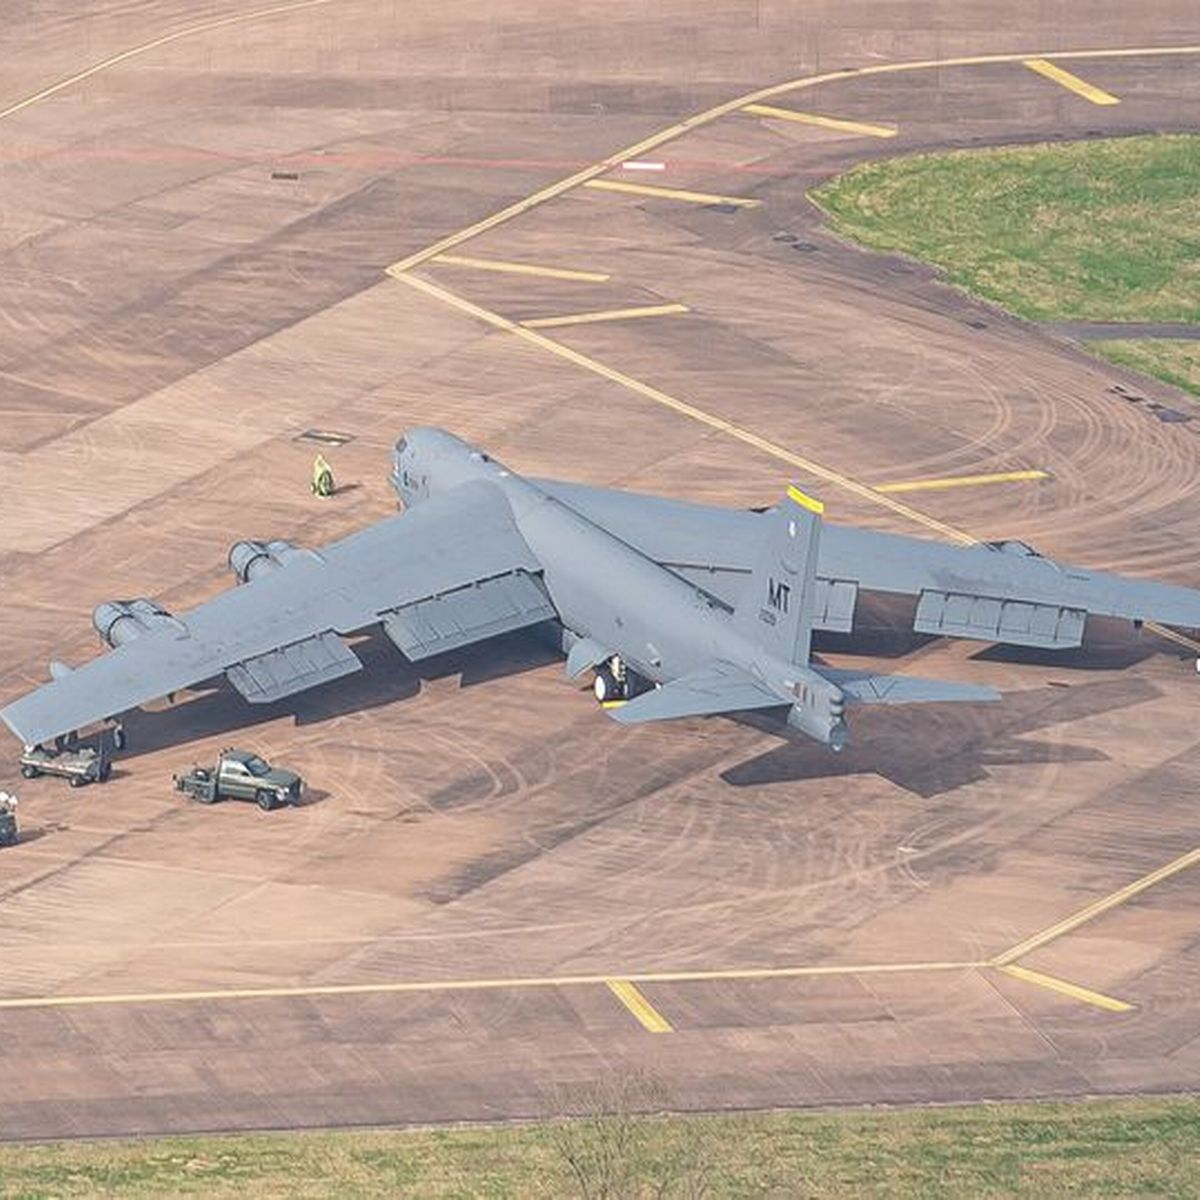How many aeroplanes would there be in the image if someone deleted zero aeroplane from the picture? 1 